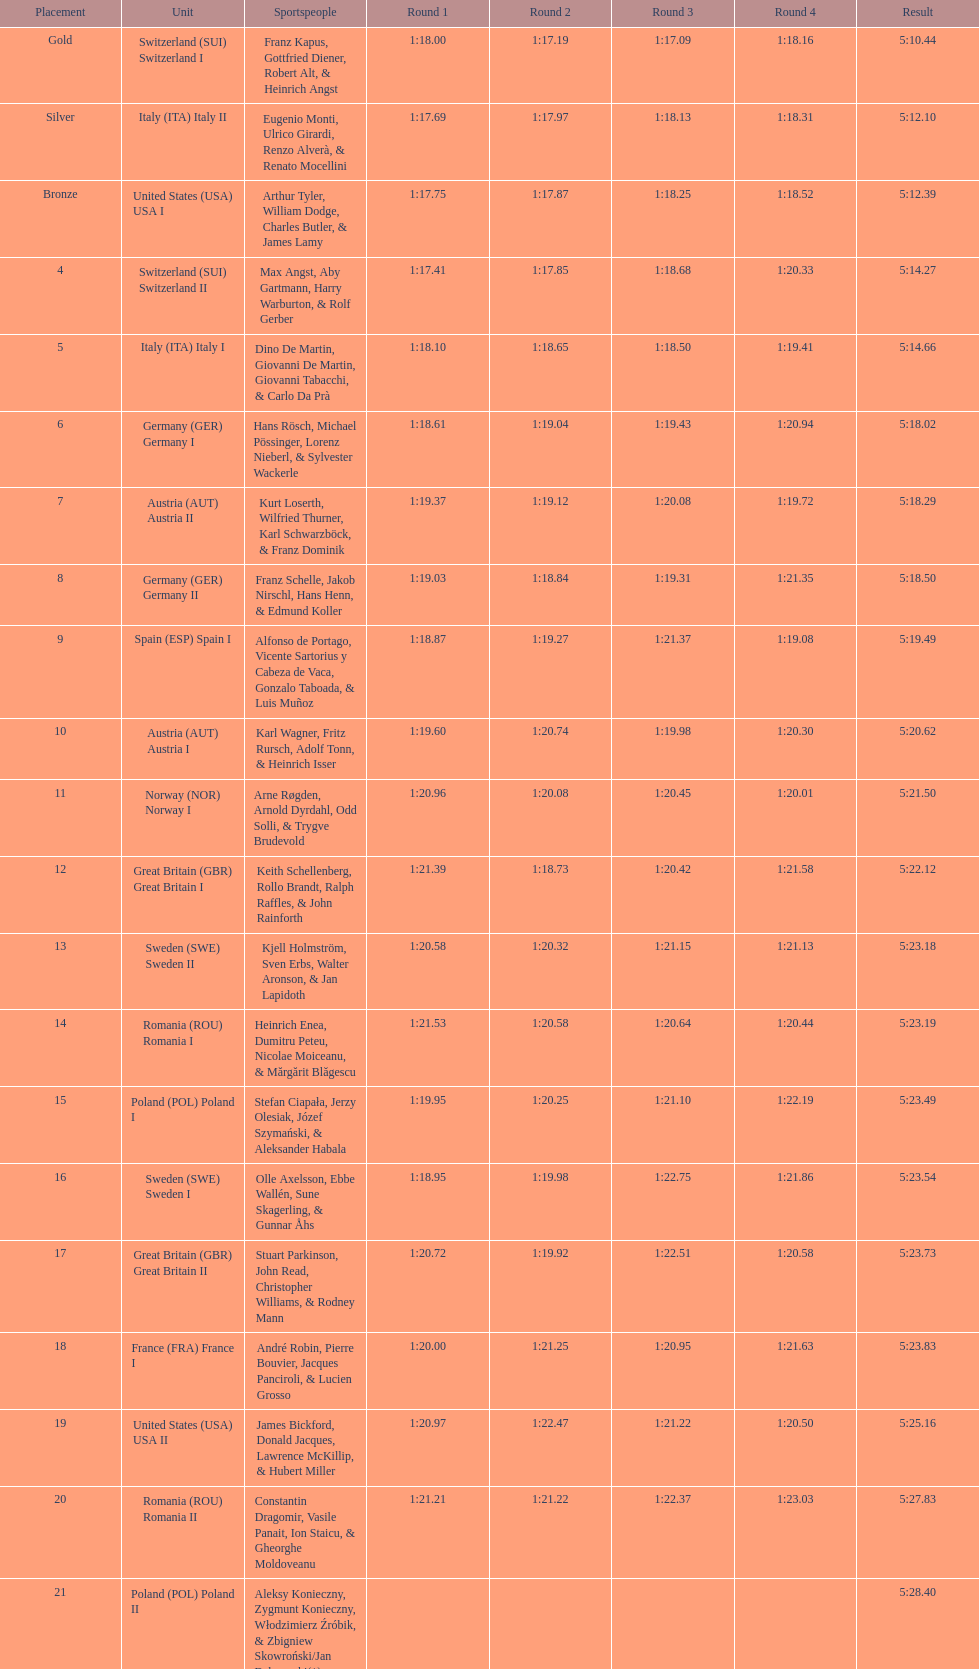What team comes after italy (ita) italy i? Germany I. 